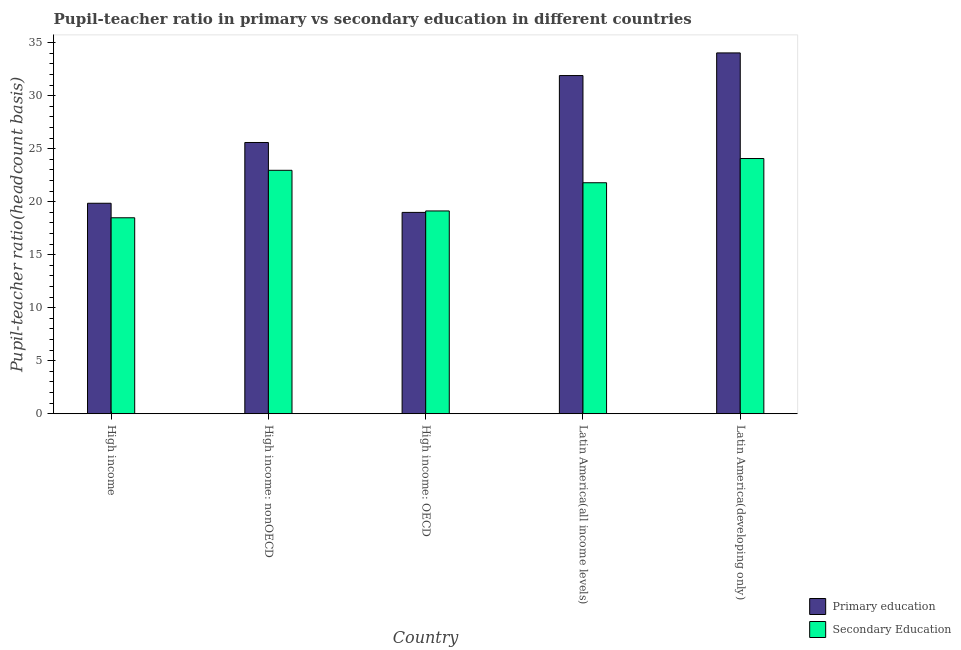Are the number of bars per tick equal to the number of legend labels?
Ensure brevity in your answer.  Yes. How many bars are there on the 3rd tick from the left?
Keep it short and to the point. 2. How many bars are there on the 3rd tick from the right?
Offer a very short reply. 2. What is the label of the 5th group of bars from the left?
Give a very brief answer. Latin America(developing only). In how many cases, is the number of bars for a given country not equal to the number of legend labels?
Your response must be concise. 0. What is the pupil-teacher ratio in primary education in High income: nonOECD?
Your answer should be very brief. 25.58. Across all countries, what is the maximum pupil teacher ratio on secondary education?
Provide a short and direct response. 24.07. Across all countries, what is the minimum pupil-teacher ratio in primary education?
Make the answer very short. 18.99. In which country was the pupil teacher ratio on secondary education maximum?
Give a very brief answer. Latin America(developing only). In which country was the pupil teacher ratio on secondary education minimum?
Offer a terse response. High income. What is the total pupil-teacher ratio in primary education in the graph?
Your answer should be compact. 130.33. What is the difference between the pupil-teacher ratio in primary education in High income and that in Latin America(developing only)?
Offer a very short reply. -14.18. What is the difference between the pupil teacher ratio on secondary education in Latin America(all income levels) and the pupil-teacher ratio in primary education in High income?
Keep it short and to the point. 1.93. What is the average pupil-teacher ratio in primary education per country?
Provide a succinct answer. 26.07. What is the difference between the pupil teacher ratio on secondary education and pupil-teacher ratio in primary education in High income?
Ensure brevity in your answer.  -1.37. In how many countries, is the pupil teacher ratio on secondary education greater than 12 ?
Your answer should be very brief. 5. What is the ratio of the pupil-teacher ratio in primary education in High income to that in High income: OECD?
Make the answer very short. 1.05. What is the difference between the highest and the second highest pupil teacher ratio on secondary education?
Give a very brief answer. 1.11. What is the difference between the highest and the lowest pupil teacher ratio on secondary education?
Provide a short and direct response. 5.59. In how many countries, is the pupil teacher ratio on secondary education greater than the average pupil teacher ratio on secondary education taken over all countries?
Make the answer very short. 3. Is the sum of the pupil-teacher ratio in primary education in High income: OECD and High income: nonOECD greater than the maximum pupil teacher ratio on secondary education across all countries?
Keep it short and to the point. Yes. What does the 2nd bar from the left in Latin America(all income levels) represents?
Provide a short and direct response. Secondary Education. What does the 2nd bar from the right in Latin America(developing only) represents?
Provide a succinct answer. Primary education. Are all the bars in the graph horizontal?
Give a very brief answer. No. What is the difference between two consecutive major ticks on the Y-axis?
Offer a terse response. 5. Does the graph contain any zero values?
Your answer should be very brief. No. Where does the legend appear in the graph?
Offer a terse response. Bottom right. How many legend labels are there?
Give a very brief answer. 2. What is the title of the graph?
Offer a very short reply. Pupil-teacher ratio in primary vs secondary education in different countries. Does "Unregistered firms" appear as one of the legend labels in the graph?
Keep it short and to the point. No. What is the label or title of the X-axis?
Keep it short and to the point. Country. What is the label or title of the Y-axis?
Keep it short and to the point. Pupil-teacher ratio(headcount basis). What is the Pupil-teacher ratio(headcount basis) in Primary education in High income?
Your response must be concise. 19.85. What is the Pupil-teacher ratio(headcount basis) of Secondary Education in High income?
Provide a succinct answer. 18.48. What is the Pupil-teacher ratio(headcount basis) in Primary education in High income: nonOECD?
Your answer should be compact. 25.58. What is the Pupil-teacher ratio(headcount basis) of Secondary Education in High income: nonOECD?
Make the answer very short. 22.96. What is the Pupil-teacher ratio(headcount basis) in Primary education in High income: OECD?
Provide a succinct answer. 18.99. What is the Pupil-teacher ratio(headcount basis) in Secondary Education in High income: OECD?
Offer a terse response. 19.12. What is the Pupil-teacher ratio(headcount basis) in Primary education in Latin America(all income levels)?
Offer a terse response. 31.89. What is the Pupil-teacher ratio(headcount basis) of Secondary Education in Latin America(all income levels)?
Keep it short and to the point. 21.78. What is the Pupil-teacher ratio(headcount basis) in Primary education in Latin America(developing only)?
Offer a very short reply. 34.03. What is the Pupil-teacher ratio(headcount basis) in Secondary Education in Latin America(developing only)?
Offer a terse response. 24.07. Across all countries, what is the maximum Pupil-teacher ratio(headcount basis) in Primary education?
Your response must be concise. 34.03. Across all countries, what is the maximum Pupil-teacher ratio(headcount basis) of Secondary Education?
Give a very brief answer. 24.07. Across all countries, what is the minimum Pupil-teacher ratio(headcount basis) in Primary education?
Make the answer very short. 18.99. Across all countries, what is the minimum Pupil-teacher ratio(headcount basis) in Secondary Education?
Offer a very short reply. 18.48. What is the total Pupil-teacher ratio(headcount basis) in Primary education in the graph?
Offer a very short reply. 130.33. What is the total Pupil-teacher ratio(headcount basis) in Secondary Education in the graph?
Give a very brief answer. 106.41. What is the difference between the Pupil-teacher ratio(headcount basis) in Primary education in High income and that in High income: nonOECD?
Your response must be concise. -5.73. What is the difference between the Pupil-teacher ratio(headcount basis) in Secondary Education in High income and that in High income: nonOECD?
Give a very brief answer. -4.48. What is the difference between the Pupil-teacher ratio(headcount basis) of Primary education in High income and that in High income: OECD?
Your answer should be compact. 0.86. What is the difference between the Pupil-teacher ratio(headcount basis) of Secondary Education in High income and that in High income: OECD?
Your answer should be compact. -0.64. What is the difference between the Pupil-teacher ratio(headcount basis) of Primary education in High income and that in Latin America(all income levels)?
Provide a succinct answer. -12.04. What is the difference between the Pupil-teacher ratio(headcount basis) in Secondary Education in High income and that in Latin America(all income levels)?
Give a very brief answer. -3.3. What is the difference between the Pupil-teacher ratio(headcount basis) in Primary education in High income and that in Latin America(developing only)?
Offer a terse response. -14.18. What is the difference between the Pupil-teacher ratio(headcount basis) in Secondary Education in High income and that in Latin America(developing only)?
Give a very brief answer. -5.59. What is the difference between the Pupil-teacher ratio(headcount basis) in Primary education in High income: nonOECD and that in High income: OECD?
Your response must be concise. 6.59. What is the difference between the Pupil-teacher ratio(headcount basis) of Secondary Education in High income: nonOECD and that in High income: OECD?
Your answer should be very brief. 3.83. What is the difference between the Pupil-teacher ratio(headcount basis) in Primary education in High income: nonOECD and that in Latin America(all income levels)?
Your answer should be compact. -6.31. What is the difference between the Pupil-teacher ratio(headcount basis) in Secondary Education in High income: nonOECD and that in Latin America(all income levels)?
Ensure brevity in your answer.  1.17. What is the difference between the Pupil-teacher ratio(headcount basis) in Primary education in High income: nonOECD and that in Latin America(developing only)?
Keep it short and to the point. -8.45. What is the difference between the Pupil-teacher ratio(headcount basis) of Secondary Education in High income: nonOECD and that in Latin America(developing only)?
Give a very brief answer. -1.11. What is the difference between the Pupil-teacher ratio(headcount basis) of Primary education in High income: OECD and that in Latin America(all income levels)?
Give a very brief answer. -12.9. What is the difference between the Pupil-teacher ratio(headcount basis) in Secondary Education in High income: OECD and that in Latin America(all income levels)?
Your answer should be compact. -2.66. What is the difference between the Pupil-teacher ratio(headcount basis) of Primary education in High income: OECD and that in Latin America(developing only)?
Ensure brevity in your answer.  -15.04. What is the difference between the Pupil-teacher ratio(headcount basis) in Secondary Education in High income: OECD and that in Latin America(developing only)?
Make the answer very short. -4.94. What is the difference between the Pupil-teacher ratio(headcount basis) in Primary education in Latin America(all income levels) and that in Latin America(developing only)?
Ensure brevity in your answer.  -2.14. What is the difference between the Pupil-teacher ratio(headcount basis) in Secondary Education in Latin America(all income levels) and that in Latin America(developing only)?
Make the answer very short. -2.28. What is the difference between the Pupil-teacher ratio(headcount basis) in Primary education in High income and the Pupil-teacher ratio(headcount basis) in Secondary Education in High income: nonOECD?
Keep it short and to the point. -3.11. What is the difference between the Pupil-teacher ratio(headcount basis) of Primary education in High income and the Pupil-teacher ratio(headcount basis) of Secondary Education in High income: OECD?
Your response must be concise. 0.73. What is the difference between the Pupil-teacher ratio(headcount basis) in Primary education in High income and the Pupil-teacher ratio(headcount basis) in Secondary Education in Latin America(all income levels)?
Give a very brief answer. -1.93. What is the difference between the Pupil-teacher ratio(headcount basis) of Primary education in High income and the Pupil-teacher ratio(headcount basis) of Secondary Education in Latin America(developing only)?
Offer a terse response. -4.22. What is the difference between the Pupil-teacher ratio(headcount basis) of Primary education in High income: nonOECD and the Pupil-teacher ratio(headcount basis) of Secondary Education in High income: OECD?
Your answer should be very brief. 6.46. What is the difference between the Pupil-teacher ratio(headcount basis) in Primary education in High income: nonOECD and the Pupil-teacher ratio(headcount basis) in Secondary Education in Latin America(all income levels)?
Your answer should be very brief. 3.79. What is the difference between the Pupil-teacher ratio(headcount basis) in Primary education in High income: nonOECD and the Pupil-teacher ratio(headcount basis) in Secondary Education in Latin America(developing only)?
Offer a very short reply. 1.51. What is the difference between the Pupil-teacher ratio(headcount basis) of Primary education in High income: OECD and the Pupil-teacher ratio(headcount basis) of Secondary Education in Latin America(all income levels)?
Offer a terse response. -2.8. What is the difference between the Pupil-teacher ratio(headcount basis) of Primary education in High income: OECD and the Pupil-teacher ratio(headcount basis) of Secondary Education in Latin America(developing only)?
Offer a very short reply. -5.08. What is the difference between the Pupil-teacher ratio(headcount basis) of Primary education in Latin America(all income levels) and the Pupil-teacher ratio(headcount basis) of Secondary Education in Latin America(developing only)?
Ensure brevity in your answer.  7.82. What is the average Pupil-teacher ratio(headcount basis) of Primary education per country?
Keep it short and to the point. 26.07. What is the average Pupil-teacher ratio(headcount basis) in Secondary Education per country?
Your answer should be very brief. 21.28. What is the difference between the Pupil-teacher ratio(headcount basis) of Primary education and Pupil-teacher ratio(headcount basis) of Secondary Education in High income?
Offer a very short reply. 1.37. What is the difference between the Pupil-teacher ratio(headcount basis) in Primary education and Pupil-teacher ratio(headcount basis) in Secondary Education in High income: nonOECD?
Ensure brevity in your answer.  2.62. What is the difference between the Pupil-teacher ratio(headcount basis) in Primary education and Pupil-teacher ratio(headcount basis) in Secondary Education in High income: OECD?
Offer a terse response. -0.14. What is the difference between the Pupil-teacher ratio(headcount basis) in Primary education and Pupil-teacher ratio(headcount basis) in Secondary Education in Latin America(all income levels)?
Ensure brevity in your answer.  10.11. What is the difference between the Pupil-teacher ratio(headcount basis) of Primary education and Pupil-teacher ratio(headcount basis) of Secondary Education in Latin America(developing only)?
Provide a short and direct response. 9.96. What is the ratio of the Pupil-teacher ratio(headcount basis) in Primary education in High income to that in High income: nonOECD?
Provide a succinct answer. 0.78. What is the ratio of the Pupil-teacher ratio(headcount basis) of Secondary Education in High income to that in High income: nonOECD?
Your answer should be very brief. 0.81. What is the ratio of the Pupil-teacher ratio(headcount basis) of Primary education in High income to that in High income: OECD?
Your answer should be compact. 1.05. What is the ratio of the Pupil-teacher ratio(headcount basis) in Secondary Education in High income to that in High income: OECD?
Give a very brief answer. 0.97. What is the ratio of the Pupil-teacher ratio(headcount basis) in Primary education in High income to that in Latin America(all income levels)?
Your response must be concise. 0.62. What is the ratio of the Pupil-teacher ratio(headcount basis) of Secondary Education in High income to that in Latin America(all income levels)?
Your response must be concise. 0.85. What is the ratio of the Pupil-teacher ratio(headcount basis) in Primary education in High income to that in Latin America(developing only)?
Your response must be concise. 0.58. What is the ratio of the Pupil-teacher ratio(headcount basis) in Secondary Education in High income to that in Latin America(developing only)?
Keep it short and to the point. 0.77. What is the ratio of the Pupil-teacher ratio(headcount basis) of Primary education in High income: nonOECD to that in High income: OECD?
Offer a terse response. 1.35. What is the ratio of the Pupil-teacher ratio(headcount basis) in Secondary Education in High income: nonOECD to that in High income: OECD?
Provide a short and direct response. 1.2. What is the ratio of the Pupil-teacher ratio(headcount basis) in Primary education in High income: nonOECD to that in Latin America(all income levels)?
Keep it short and to the point. 0.8. What is the ratio of the Pupil-teacher ratio(headcount basis) of Secondary Education in High income: nonOECD to that in Latin America(all income levels)?
Offer a very short reply. 1.05. What is the ratio of the Pupil-teacher ratio(headcount basis) in Primary education in High income: nonOECD to that in Latin America(developing only)?
Offer a very short reply. 0.75. What is the ratio of the Pupil-teacher ratio(headcount basis) of Secondary Education in High income: nonOECD to that in Latin America(developing only)?
Offer a terse response. 0.95. What is the ratio of the Pupil-teacher ratio(headcount basis) in Primary education in High income: OECD to that in Latin America(all income levels)?
Offer a terse response. 0.6. What is the ratio of the Pupil-teacher ratio(headcount basis) in Secondary Education in High income: OECD to that in Latin America(all income levels)?
Your answer should be very brief. 0.88. What is the ratio of the Pupil-teacher ratio(headcount basis) in Primary education in High income: OECD to that in Latin America(developing only)?
Give a very brief answer. 0.56. What is the ratio of the Pupil-teacher ratio(headcount basis) in Secondary Education in High income: OECD to that in Latin America(developing only)?
Offer a very short reply. 0.79. What is the ratio of the Pupil-teacher ratio(headcount basis) of Primary education in Latin America(all income levels) to that in Latin America(developing only)?
Make the answer very short. 0.94. What is the ratio of the Pupil-teacher ratio(headcount basis) in Secondary Education in Latin America(all income levels) to that in Latin America(developing only)?
Keep it short and to the point. 0.91. What is the difference between the highest and the second highest Pupil-teacher ratio(headcount basis) of Primary education?
Offer a terse response. 2.14. What is the difference between the highest and the second highest Pupil-teacher ratio(headcount basis) of Secondary Education?
Offer a very short reply. 1.11. What is the difference between the highest and the lowest Pupil-teacher ratio(headcount basis) of Primary education?
Make the answer very short. 15.04. What is the difference between the highest and the lowest Pupil-teacher ratio(headcount basis) in Secondary Education?
Your answer should be very brief. 5.59. 